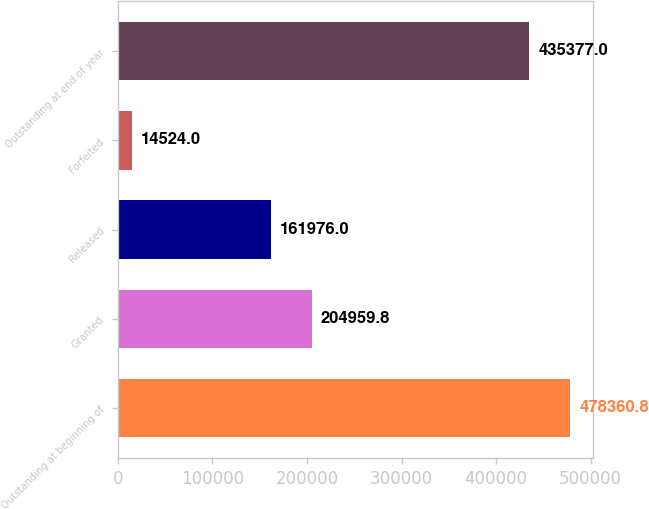Convert chart to OTSL. <chart><loc_0><loc_0><loc_500><loc_500><bar_chart><fcel>Outstanding at beginning of<fcel>Granted<fcel>Released<fcel>Forfeited<fcel>Outstanding at end of year<nl><fcel>478361<fcel>204960<fcel>161976<fcel>14524<fcel>435377<nl></chart> 